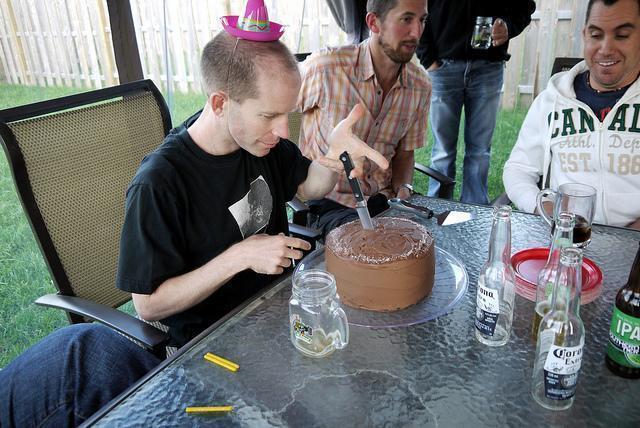What is in the cake?
Answer the question by selecting the correct answer among the 4 following choices and explain your choice with a short sentence. The answer should be formatted with the following format: `Answer: choice
Rationale: rationale.`
Options: Fork, knife, babys finger, spatula. Answer: knife.
Rationale: The chocolate cake on the table has a sharp knife sticking into it. 